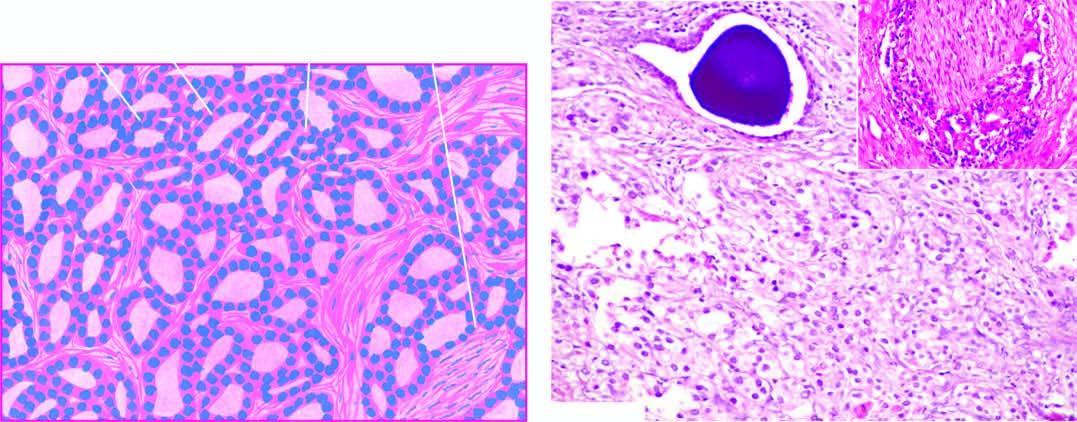what does inset in the photomicrograph show by prostatic adenocarcinoma?
Answer the question using a single word or phrase. Perineural invasion by prostatic adenocarcinoma 